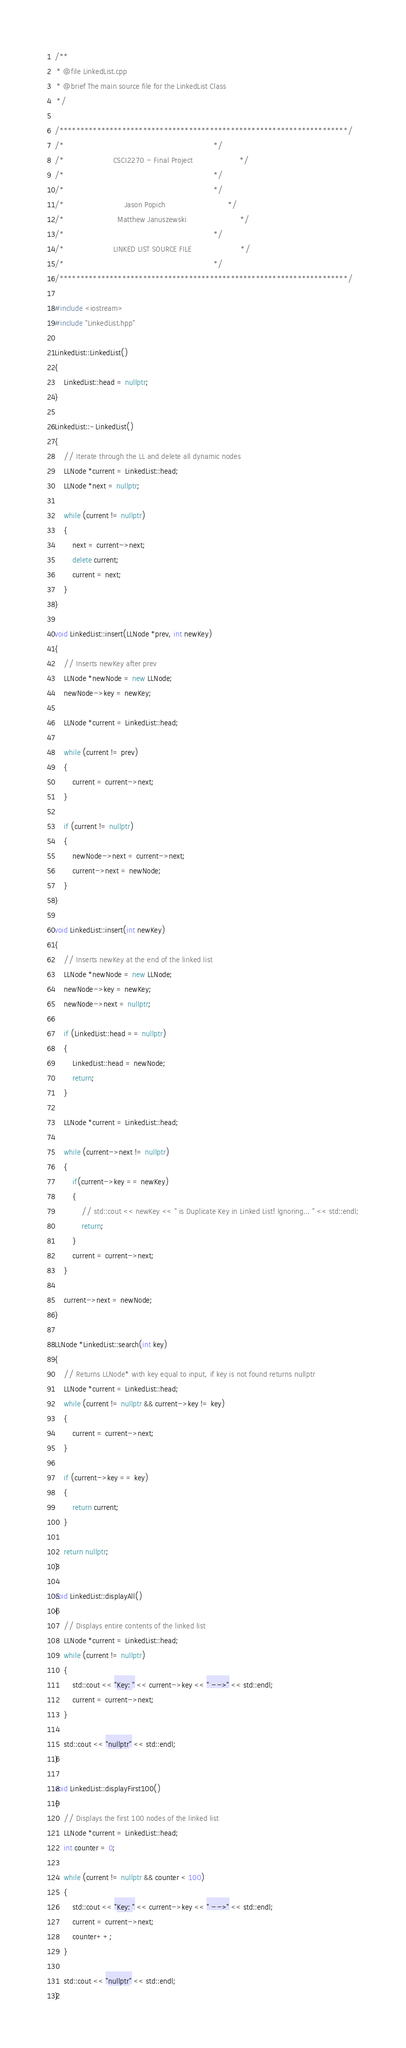<code> <loc_0><loc_0><loc_500><loc_500><_C++_>/**
 * @file LinkedList.cpp
 * @brief The main source file for the LinkedList Class
 */

/*********************************************************************/
/*                                                                   */
/*                      CSCI2270 - Final Project                     */
/*                                                                   */
/*                                                                   */
/*                           Jason Popich                            */
/*                        Matthew Januszewski                        */
/*                                                                   */
/*                      LINKED LIST SOURCE FILE                      */
/*                                                                   */
/*********************************************************************/

#include <iostream>
#include "LinkedList.hpp"

LinkedList::LinkedList()
{
    LinkedList::head = nullptr;
}

LinkedList::~LinkedList()
{
    // Iterate through the LL and delete all dynamic nodes
    LLNode *current = LinkedList::head;
    LLNode *next = nullptr;

    while (current != nullptr)
    {
        next = current->next;
        delete current;
        current = next;
    }
}

void LinkedList::insert(LLNode *prev, int newKey)
{
    // Inserts newKey after prev
    LLNode *newNode = new LLNode;
    newNode->key = newKey;

    LLNode *current = LinkedList::head;

    while (current != prev)
    {
        current = current->next;
    }

    if (current != nullptr)
    {
        newNode->next = current->next;
        current->next = newNode;
    }
}

void LinkedList::insert(int newKey)
{
    // Inserts newKey at the end of the linked list
    LLNode *newNode = new LLNode;
    newNode->key = newKey;
    newNode->next = nullptr;

    if (LinkedList::head == nullptr)
    {
        LinkedList::head = newNode;
        return;
    }

    LLNode *current = LinkedList::head;

    while (current->next != nullptr)
    {
        if(current->key == newKey)
        {
            // std::cout << newKey << " is Duplicate Key in Linked List! Ignoring... " << std::endl;
            return;
        }
        current = current->next;
    }

    current->next = newNode;
}

LLNode *LinkedList::search(int key)
{
    // Returns LLNode* with key equal to input, if key is not found returns nullptr
    LLNode *current = LinkedList::head;
    while (current != nullptr && current->key != key)
    {
        current = current->next;
    }

    if (current->key == key)
    {
        return current;
    }

    return nullptr;
}

void LinkedList::displayAll()
{
    // Displays entire contents of the linked list
    LLNode *current = LinkedList::head;
    while (current != nullptr)
    {
        std::cout << "Key: " << current->key << " -->" << std::endl;
        current = current->next;
    }

    std::cout << "nullptr" << std::endl;
}

void LinkedList::displayFirst100()
{
    // Displays the first 100 nodes of the linked list
    LLNode *current = LinkedList::head;
    int counter = 0;

    while (current != nullptr && counter < 100)
    {
        std::cout << "Key: " << current->key << " -->" << std::endl;
        current = current->next;
        counter++;
    }

    std::cout << "nullptr" << std::endl;
}</code> 